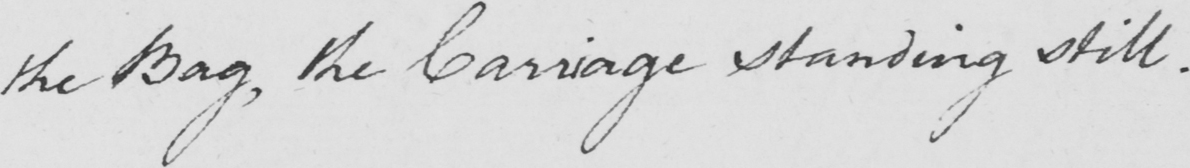Please provide the text content of this handwritten line. the Bag , the Carriage standing still . 